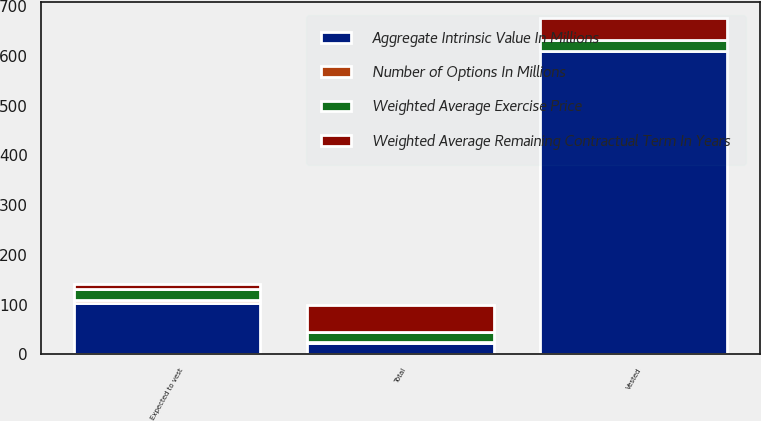Convert chart. <chart><loc_0><loc_0><loc_500><loc_500><stacked_bar_chart><ecel><fcel>Vested<fcel>Expected to vest<fcel>Total<nl><fcel>Weighted Average Remaining Contractual Term In Years<fcel>43.8<fcel>9.6<fcel>53.4<nl><fcel>Weighted Average Exercise Price<fcel>21.07<fcel>24.07<fcel>21.61<nl><fcel>Number of Options In Millions<fcel>1.8<fcel>4.1<fcel>2.2<nl><fcel>Aggregate Intrinsic Value In Millions<fcel>609<fcel>104<fcel>21.61<nl></chart> 